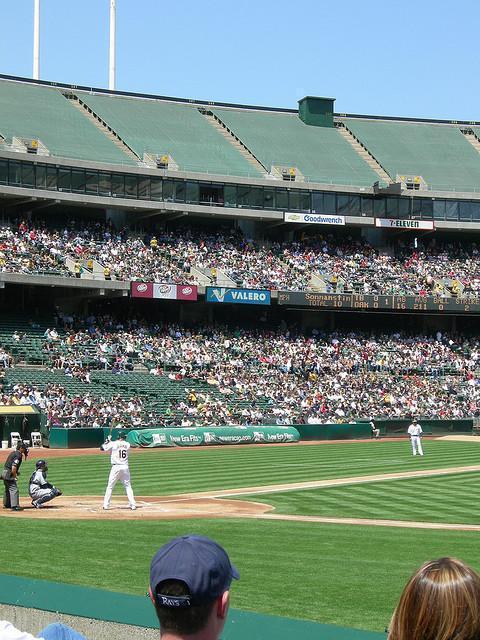The man wearing what color of shirt enforces the rules of the game?
Pick the right solution, then justify: 'Answer: answer
Rationale: rationale.'
Options: Grey, white, red, black. Answer: black.
Rationale: This is the uniform for umpires in baseball 